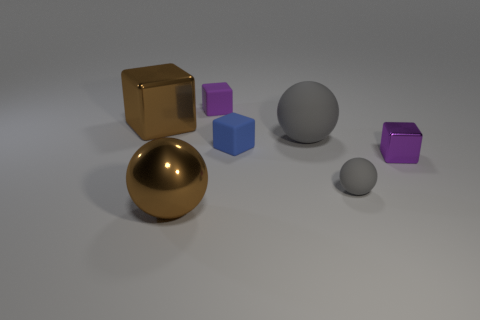Can you speculate on the purpose of this arrangement of objects? This arrangement seems artistic, perhaps intended to demonstrate contrast in colors, shapes, and materials. It resembles a 3D rendering used in a visual arts project or a graphics software test, showcasing the rendering capabilities like reflections, lighting, and texture. 